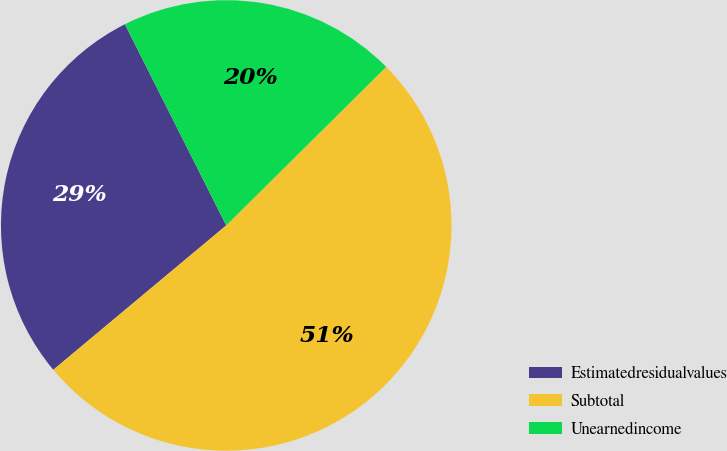Convert chart to OTSL. <chart><loc_0><loc_0><loc_500><loc_500><pie_chart><fcel>Estimatedresidualvalues<fcel>Subtotal<fcel>Unearnedincome<nl><fcel>28.65%<fcel>51.36%<fcel>20.0%<nl></chart> 